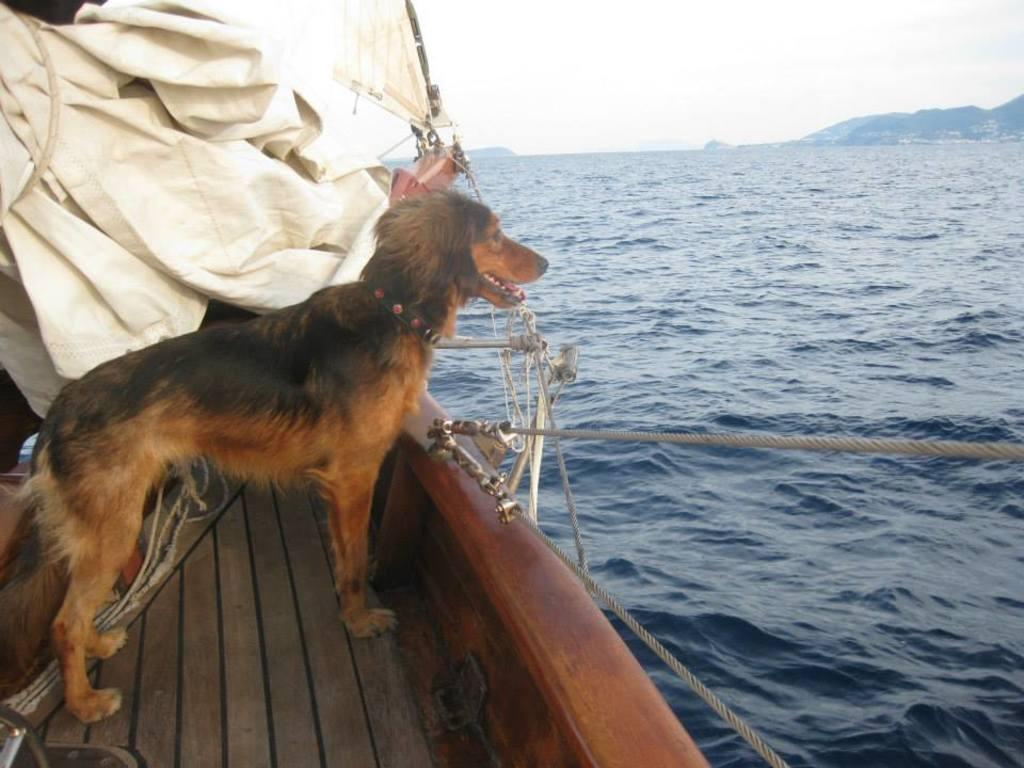What animal is present in the image? There is a dog in the image. Where is the dog located? The dog is standing on a boat. What can be seen around the boat in the image? There is water visible in the image. What is visible in the distance in the image? There are hills in the background of the image. What part of the natural environment is visible in the image? The sky is visible in the image. What type of whistle can be heard coming from the dog in the image? There is no whistle present in the image, and the dog is not making any sounds. 